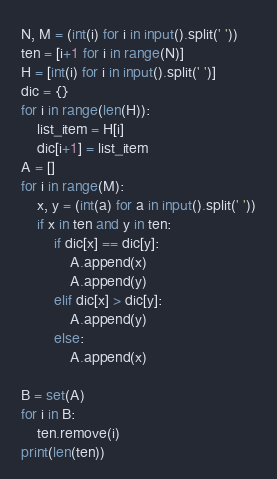<code> <loc_0><loc_0><loc_500><loc_500><_Python_>N, M = (int(i) for i in input().split(' '))
ten = [i+1 for i in range(N)]
H = [int(i) for i in input().split(' ')]
dic = {}
for i in range(len(H)):
    list_item = H[i]
    dic[i+1] = list_item
A = []
for i in range(M):
    x, y = (int(a) for a in input().split(' '))
    if x in ten and y in ten:
        if dic[x] == dic[y]:
            A.append(x)
            A.append(y)
        elif dic[x] > dic[y]:
            A.append(y)
        else:
            A.append(x)
    
B = set(A)
for i in B:
    ten.remove(i)
print(len(ten))</code> 